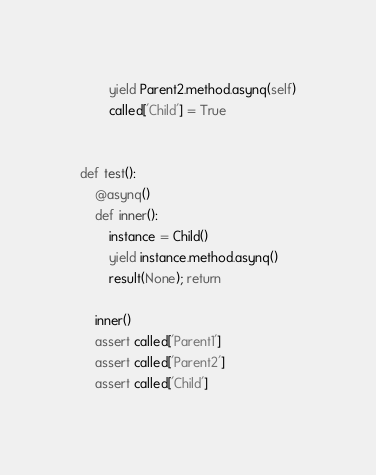<code> <loc_0><loc_0><loc_500><loc_500><_Python_>        yield Parent2.method.asynq(self)
        called['Child'] = True


def test():
    @asynq()
    def inner():
        instance = Child()
        yield instance.method.asynq()
        result(None); return

    inner()
    assert called['Parent1']
    assert called['Parent2']
    assert called['Child']
</code> 